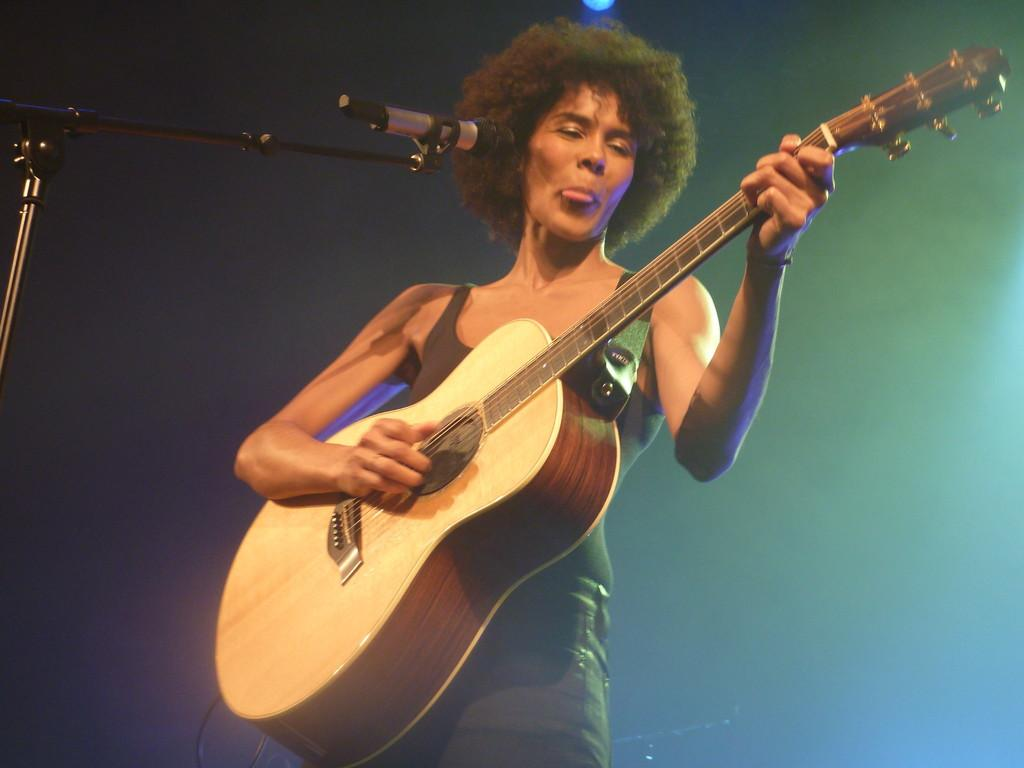What is the main subject of the image? There is a person in the image. What is the person doing in the image? The person is playing a guitar. What object is present in the image that is typically used for amplifying sound? There is a microphone in the image. How would you describe the background of the image? The background of the image has a dark view. What type of orange patch can be seen on the kite in the image? There is no orange patch or kite present in the image. 